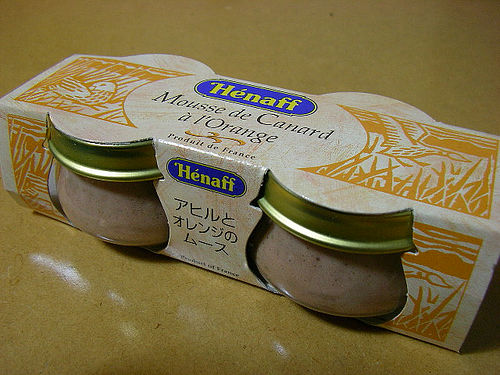<image>
Can you confirm if the jar is in front of the package? No. The jar is not in front of the package. The spatial positioning shows a different relationship between these objects. 